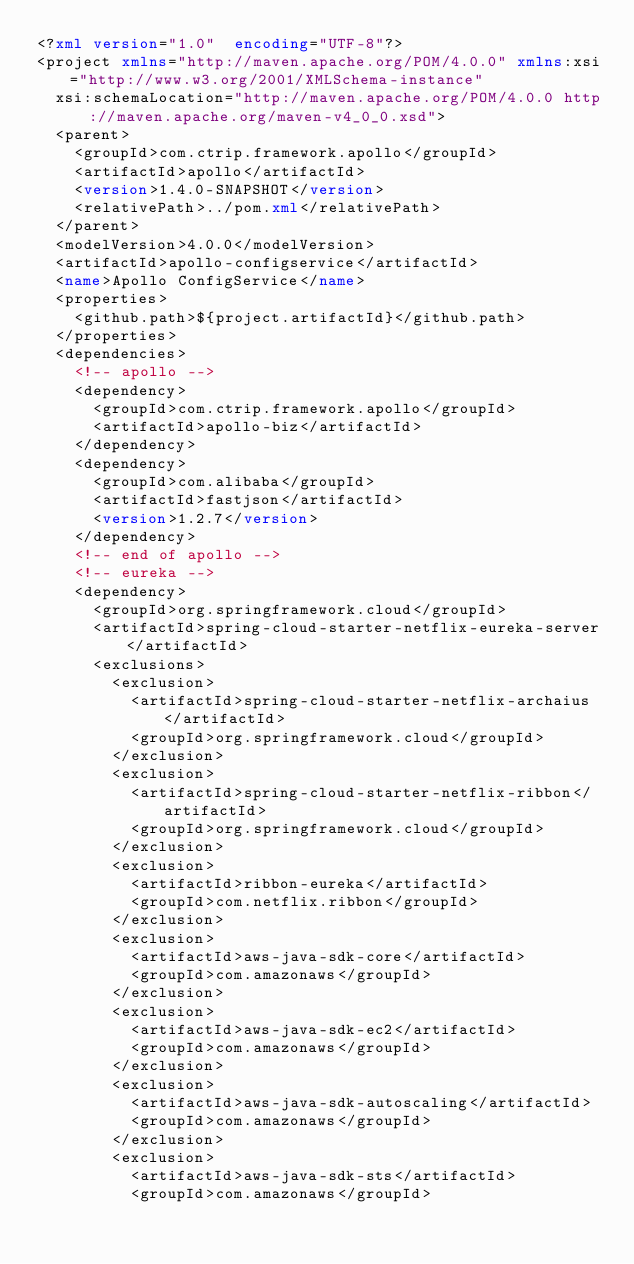<code> <loc_0><loc_0><loc_500><loc_500><_XML_><?xml version="1.0"  encoding="UTF-8"?>
<project xmlns="http://maven.apache.org/POM/4.0.0" xmlns:xsi="http://www.w3.org/2001/XMLSchema-instance"
	xsi:schemaLocation="http://maven.apache.org/POM/4.0.0 http://maven.apache.org/maven-v4_0_0.xsd">
	<parent>
		<groupId>com.ctrip.framework.apollo</groupId>
		<artifactId>apollo</artifactId>
		<version>1.4.0-SNAPSHOT</version>
		<relativePath>../pom.xml</relativePath>
	</parent>
	<modelVersion>4.0.0</modelVersion>
	<artifactId>apollo-configservice</artifactId>
	<name>Apollo ConfigService</name>
	<properties>
		<github.path>${project.artifactId}</github.path>
	</properties>
	<dependencies>
		<!-- apollo -->
		<dependency>
			<groupId>com.ctrip.framework.apollo</groupId>
			<artifactId>apollo-biz</artifactId>
		</dependency>
		<dependency>
			<groupId>com.alibaba</groupId>
			<artifactId>fastjson</artifactId>
			<version>1.2.7</version>
		</dependency>
		<!-- end of apollo -->
		<!-- eureka -->
		<dependency>
			<groupId>org.springframework.cloud</groupId>
			<artifactId>spring-cloud-starter-netflix-eureka-server</artifactId>
			<exclusions>
				<exclusion>
					<artifactId>spring-cloud-starter-netflix-archaius</artifactId>
					<groupId>org.springframework.cloud</groupId>
				</exclusion>
				<exclusion>
					<artifactId>spring-cloud-starter-netflix-ribbon</artifactId>
					<groupId>org.springframework.cloud</groupId>
				</exclusion>
				<exclusion>
					<artifactId>ribbon-eureka</artifactId>
					<groupId>com.netflix.ribbon</groupId>
				</exclusion>
				<exclusion>
					<artifactId>aws-java-sdk-core</artifactId>
					<groupId>com.amazonaws</groupId>
				</exclusion>
				<exclusion>
					<artifactId>aws-java-sdk-ec2</artifactId>
					<groupId>com.amazonaws</groupId>
				</exclusion>
				<exclusion>
					<artifactId>aws-java-sdk-autoscaling</artifactId>
					<groupId>com.amazonaws</groupId>
				</exclusion>
				<exclusion>
					<artifactId>aws-java-sdk-sts</artifactId>
					<groupId>com.amazonaws</groupId></code> 